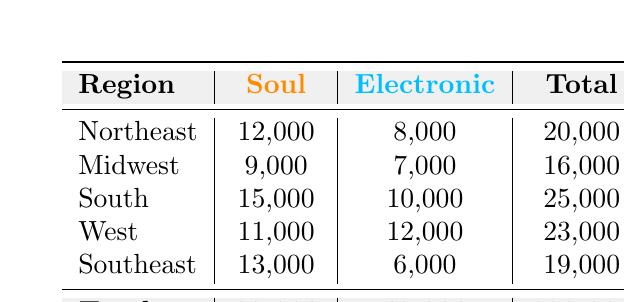What is the total attendance for the South region? The South region has an attendance of 15,000 for Soul music and 10,000 for Electronic music. Summing these values gives 15,000 + 10,000 = 25,000.
Answer: 25,000 Which region had the highest attendance for Electronic music? By checking the attendance values for Electronic music across all regions, West has an attendance of 12,000, while South has 10,000, Northeast has 8,000, Midwest has 7,000, and Southeast has 6,000. Therefore, West has the highest attendance.
Answer: West What is the total attendance for Soul music across all regions? The total attendance for Soul music can be found by adding 12,000 (Northeast) + 9,000 (Midwest) + 15,000 (South) + 11,000 (West) + 13,000 (Southeast) which equals 60,000.
Answer: 60,000 Is the attendance for Electronic music in the Southeast region greater than the attendance for Soul music in the Northeast region? The attendance for Electronic music in the Southeast is 6,000 while the Soul music attendance in the Northeast is 12,000. Since 6,000 is less than 12,000, the statement is false.
Answer: No What is the average attendance for both music types in the Midwest region? The total attendance for the Midwest region is 9,000 for Soul and 7,000 for Electronic music. Summing these gives 9,000 + 7,000 = 16,000. To find the average, divide by the number of music types (2): 16,000 / 2 = 8,000.
Answer: 8,000 Which music type had a higher total attendance overall? The total attendance for Soul music is 60,000, while for Electronic music it is 43,000. Since 60,000 is greater than 43,000, Soul music has a higher overall attendance.
Answer: Soul What is the difference in attendance between the South and Northeast regions for Soul music? For Soul music, the South has an attendance of 15,000 and the Northeast has an attendance of 12,000. The difference is calculated as 15,000 - 12,000 = 3,000.
Answer: 3,000 Is the total attendance for the West region greater than the average attendance of both music types across all regions? The total attendance for the West is 23,000. First, calculate the overall total attendance which is 103,000. Since there are 5 regions, the average is 103,000 / 5 = 20,600. Comparing 23,000 to 20,600 shows that 23,000 is indeed greater.
Answer: Yes What is the combined attendance for Electronic music in the Northeast and Midwest regions? The attendance for Electronic music is 8,000 in the Northeast and 7,000 in the Midwest. Adding these gives 8,000 + 7,000 = 15,000.
Answer: 15,000 